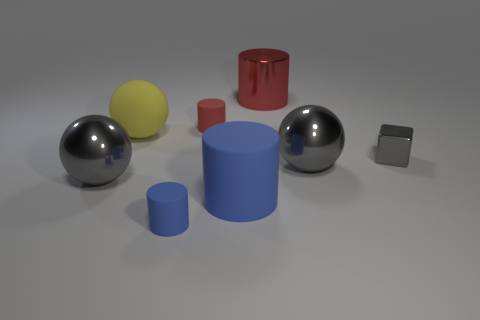Is there anything else that has the same shape as the tiny blue rubber object?
Your answer should be very brief. Yes. Do the metallic cylinder and the yellow rubber object have the same size?
Ensure brevity in your answer.  Yes. What is the material of the gray sphere that is to the right of the gray metal sphere that is on the left side of the ball that is right of the small blue cylinder?
Provide a succinct answer. Metal. Is the number of yellow things that are behind the red metallic object the same as the number of tiny gray shiny things?
Ensure brevity in your answer.  No. Are there any other things that are the same size as the yellow matte ball?
Offer a terse response. Yes. How many objects are either yellow metal cylinders or large metallic balls?
Your answer should be compact. 2. The small red thing that is the same material as the big blue object is what shape?
Provide a short and direct response. Cylinder. What is the size of the rubber cylinder that is behind the large cylinder in front of the big shiny cylinder?
Give a very brief answer. Small. What number of big things are blue rubber cylinders or metal things?
Offer a very short reply. 4. How many other things are the same color as the block?
Give a very brief answer. 2. 